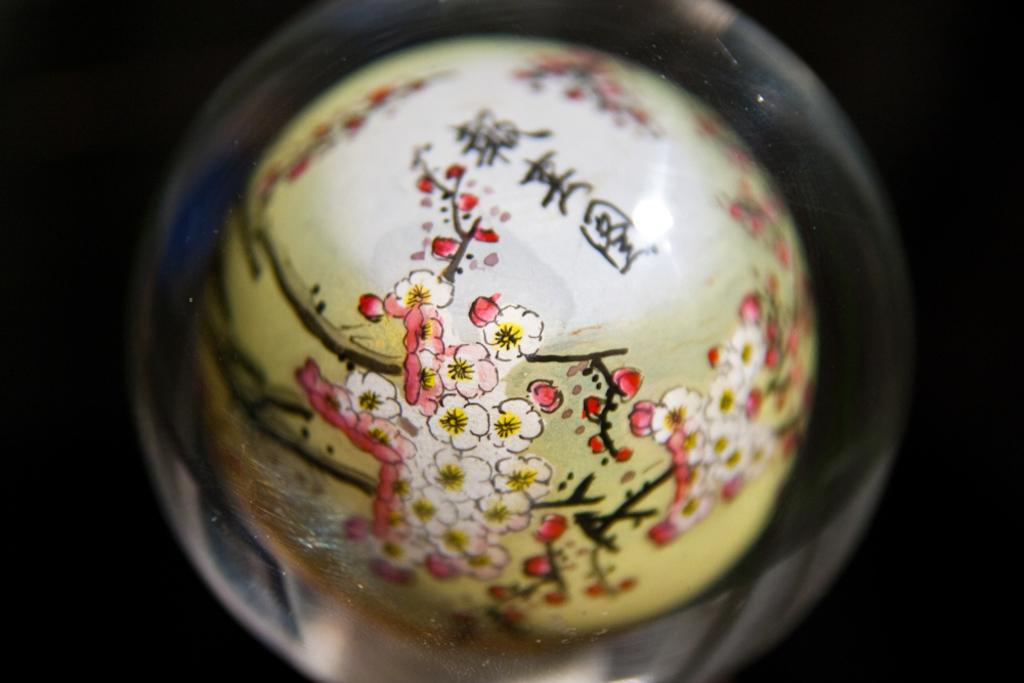What is the main object in the center of the image? There is a ceramic in the center of the image. Can you describe the ceramic in more detail? Unfortunately, the provided facts do not offer any additional details about the ceramic. How many zebras are standing on top of the cakes in the image? There are no cakes or zebras present in the image. 